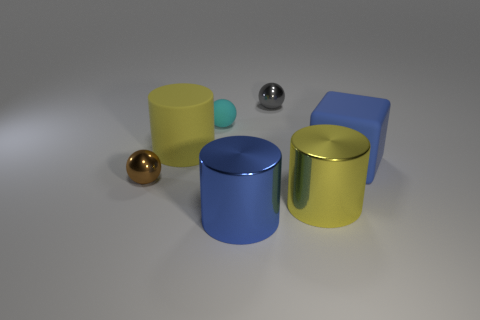Add 2 small gray metal balls. How many objects exist? 9 Subtract all cylinders. How many objects are left? 4 Add 1 blue rubber things. How many blue rubber things are left? 2 Add 2 big red matte cylinders. How many big red matte cylinders exist? 2 Subtract 0 purple blocks. How many objects are left? 7 Subtract all large green rubber things. Subtract all big yellow things. How many objects are left? 5 